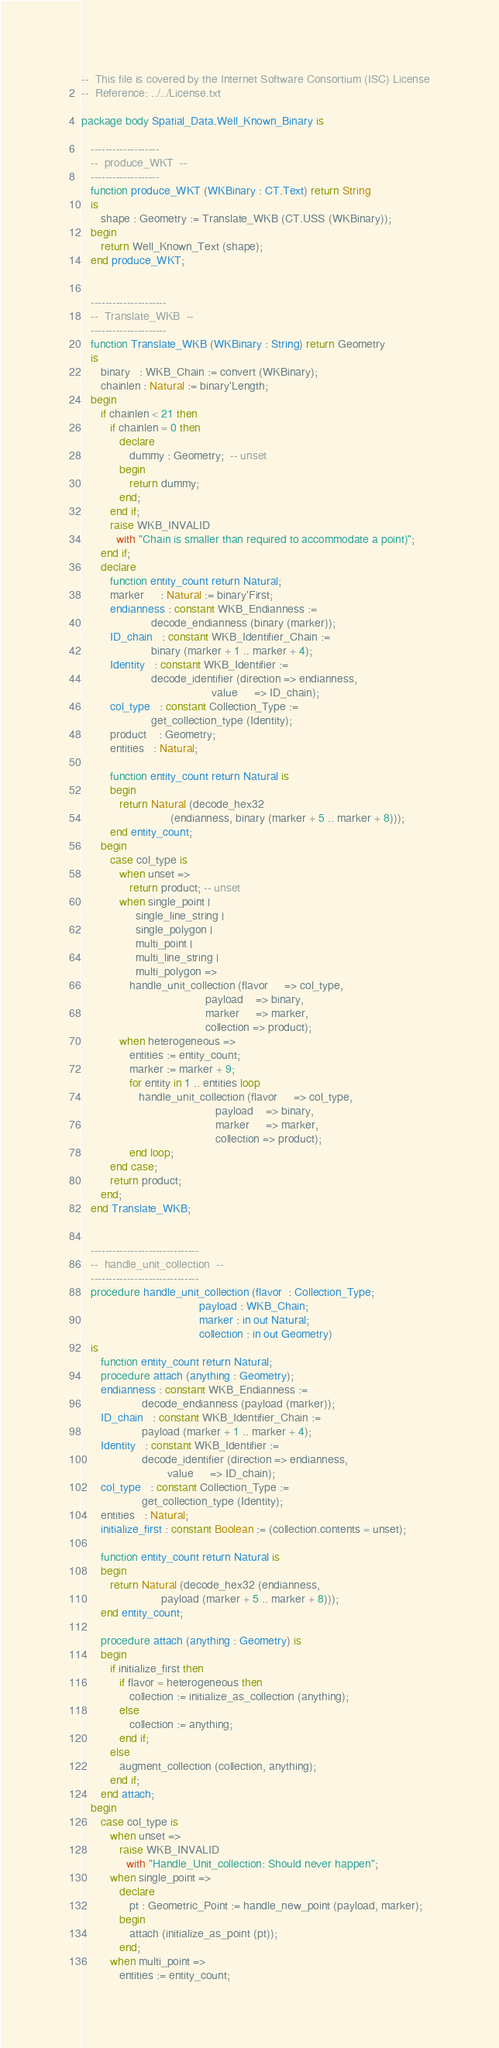Convert code to text. <code><loc_0><loc_0><loc_500><loc_500><_Ada_>--  This file is covered by the Internet Software Consortium (ISC) License
--  Reference: ../../License.txt

package body Spatial_Data.Well_Known_Binary is

   -------------------
   --  produce_WKT  --
   -------------------
   function produce_WKT (WKBinary : CT.Text) return String
   is
      shape : Geometry := Translate_WKB (CT.USS (WKBinary));
   begin
      return Well_Known_Text (shape);
   end produce_WKT;


   ---------------------
   --  Translate_WKB  --
   ---------------------
   function Translate_WKB (WKBinary : String) return Geometry
   is
      binary   : WKB_Chain := convert (WKBinary);
      chainlen : Natural := binary'Length;
   begin
      if chainlen < 21 then
         if chainlen = 0 then
            declare
               dummy : Geometry;  -- unset
            begin
               return dummy;
            end;
         end if;
         raise WKB_INVALID
           with "Chain is smaller than required to accommodate a point)";
      end if;
      declare
         function entity_count return Natural;
         marker     : Natural := binary'First;
         endianness : constant WKB_Endianness :=
                      decode_endianness (binary (marker));
         ID_chain   : constant WKB_Identifier_Chain :=
                      binary (marker + 1 .. marker + 4);
         Identity   : constant WKB_Identifier :=
                      decode_identifier (direction => endianness,
                                         value     => ID_chain);
         col_type   : constant Collection_Type :=
                      get_collection_type (Identity);
         product    : Geometry;
         entities   : Natural;

         function entity_count return Natural is
         begin
            return Natural (decode_hex32
                            (endianness, binary (marker + 5 .. marker + 8)));
         end entity_count;
      begin
         case col_type is
            when unset =>
               return product; -- unset
            when single_point |
                 single_line_string |
                 single_polygon |
                 multi_point |
                 multi_line_string |
                 multi_polygon =>
               handle_unit_collection (flavor     => col_type,
                                       payload    => binary,
                                       marker     => marker,
                                       collection => product);
            when heterogeneous =>
               entities := entity_count;
               marker := marker + 9;
               for entity in 1 .. entities loop
                  handle_unit_collection (flavor     => col_type,
                                          payload    => binary,
                                          marker     => marker,
                                          collection => product);
               end loop;
         end case;
         return product;
      end;
   end Translate_WKB;


   ------------------------------
   --  handle_unit_collection  --
   ------------------------------
   procedure handle_unit_collection (flavor  : Collection_Type;
                                     payload : WKB_Chain;
                                     marker : in out Natural;
                                     collection : in out Geometry)
   is
      function entity_count return Natural;
      procedure attach (anything : Geometry);
      endianness : constant WKB_Endianness :=
                   decode_endianness (payload (marker));
      ID_chain   : constant WKB_Identifier_Chain :=
                   payload (marker + 1 .. marker + 4);
      Identity   : constant WKB_Identifier :=
                   decode_identifier (direction => endianness,
                           value     => ID_chain);
      col_type   : constant Collection_Type :=
                   get_collection_type (Identity);
      entities   : Natural;
      initialize_first : constant Boolean := (collection.contents = unset);

      function entity_count return Natural is
      begin
         return Natural (decode_hex32 (endianness,
                         payload (marker + 5 .. marker + 8)));
      end entity_count;

      procedure attach (anything : Geometry) is
      begin
         if initialize_first then
            if flavor = heterogeneous then
               collection := initialize_as_collection (anything);
            else
               collection := anything;
            end if;
         else
            augment_collection (collection, anything);
         end if;
      end attach;
   begin
      case col_type is
         when unset =>
            raise WKB_INVALID
              with "Handle_Unit_collection: Should never happen";
         when single_point =>
            declare
               pt : Geometric_Point := handle_new_point (payload, marker);
            begin
               attach (initialize_as_point (pt));
            end;
         when multi_point =>
            entities := entity_count;</code> 